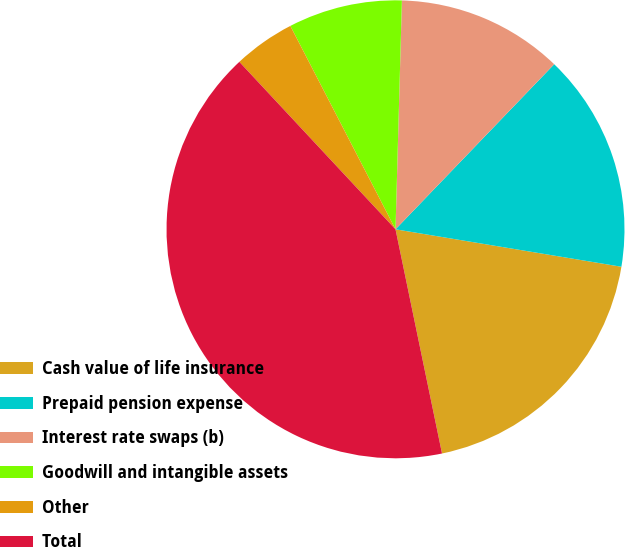Convert chart. <chart><loc_0><loc_0><loc_500><loc_500><pie_chart><fcel>Cash value of life insurance<fcel>Prepaid pension expense<fcel>Interest rate swaps (b)<fcel>Goodwill and intangible assets<fcel>Other<fcel>Total<nl><fcel>19.13%<fcel>15.43%<fcel>11.74%<fcel>8.04%<fcel>4.35%<fcel>41.31%<nl></chart> 